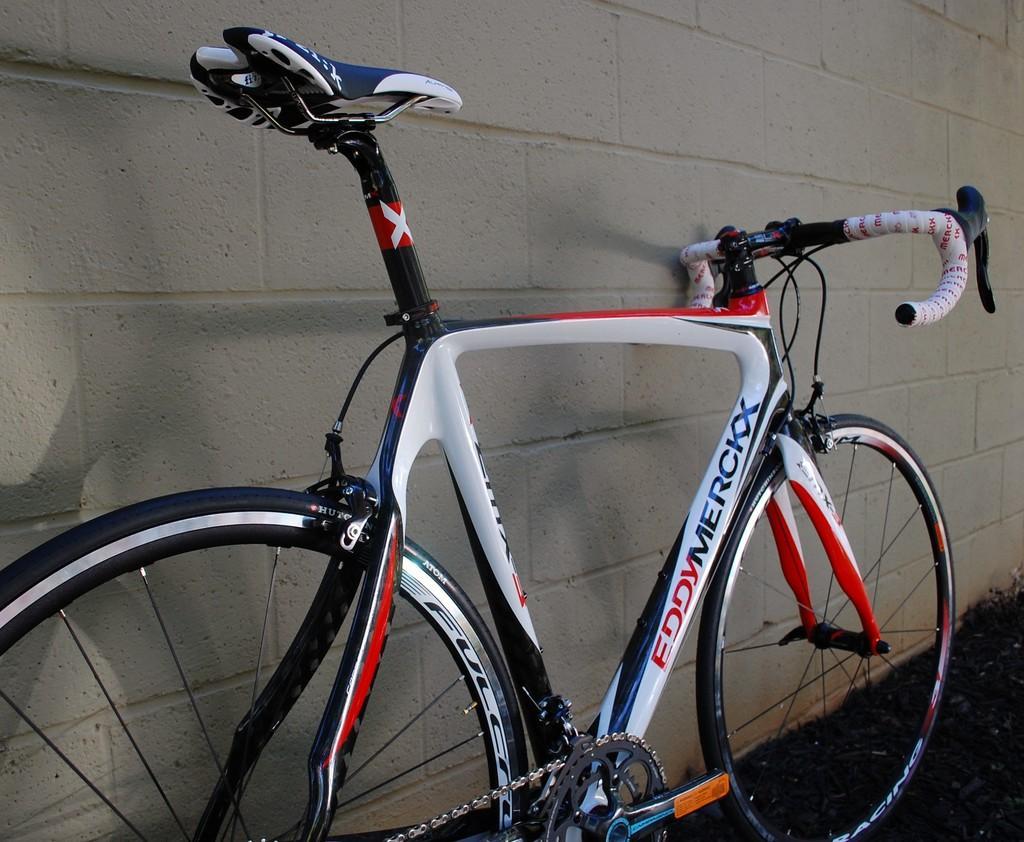How would you summarize this image in a sentence or two? In front of the image there is a cycle. Behind the cycle there is a wall. 